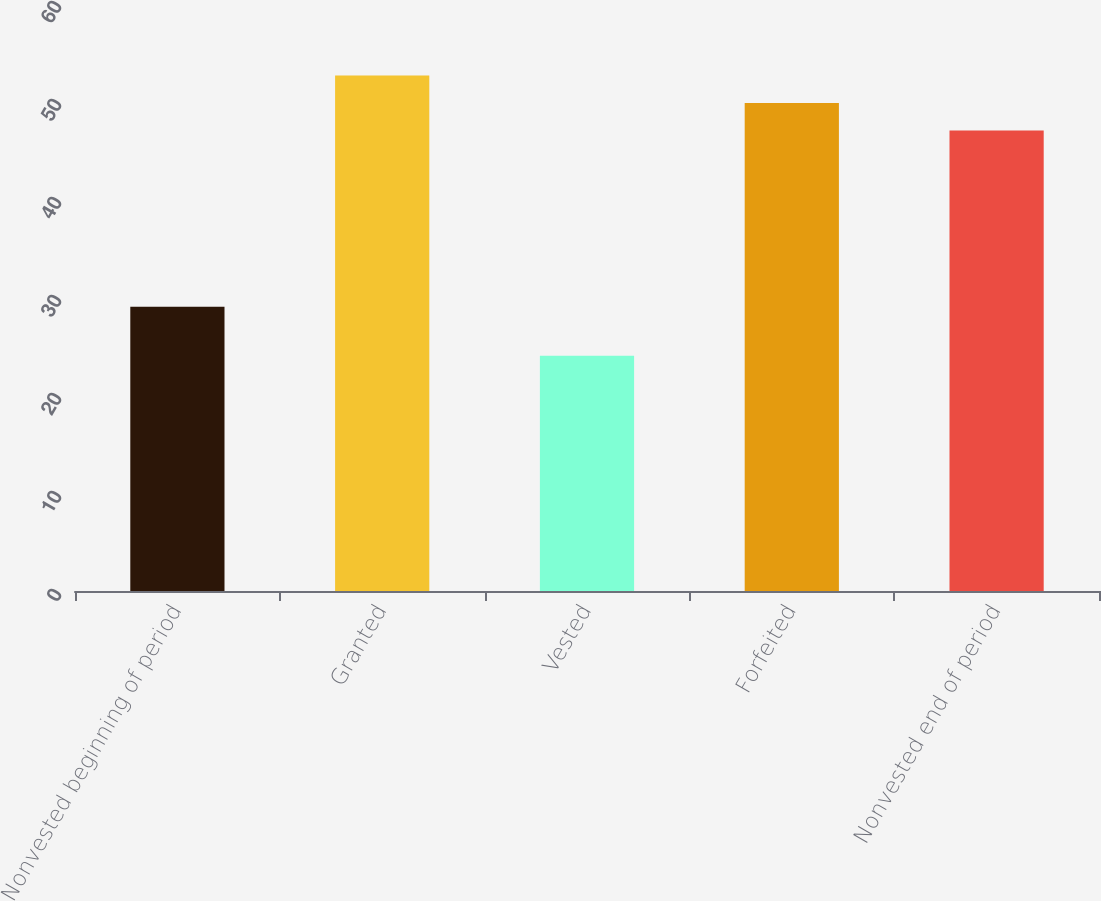Convert chart. <chart><loc_0><loc_0><loc_500><loc_500><bar_chart><fcel>Nonvested beginning of period<fcel>Granted<fcel>Vested<fcel>Forfeited<fcel>Nonvested end of period<nl><fcel>29<fcel>52.6<fcel>24<fcel>49.8<fcel>47<nl></chart> 